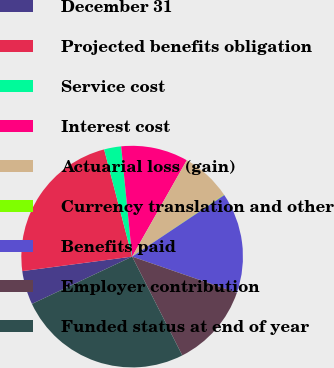Convert chart. <chart><loc_0><loc_0><loc_500><loc_500><pie_chart><fcel>December 31<fcel>Projected benefits obligation<fcel>Service cost<fcel>Interest cost<fcel>Actuarial loss (gain)<fcel>Currency translation and other<fcel>Benefits paid<fcel>Employer contribution<fcel>Funded status at end of year<nl><fcel>4.93%<fcel>23.02%<fcel>2.49%<fcel>9.79%<fcel>7.36%<fcel>0.06%<fcel>14.66%<fcel>12.23%<fcel>25.46%<nl></chart> 